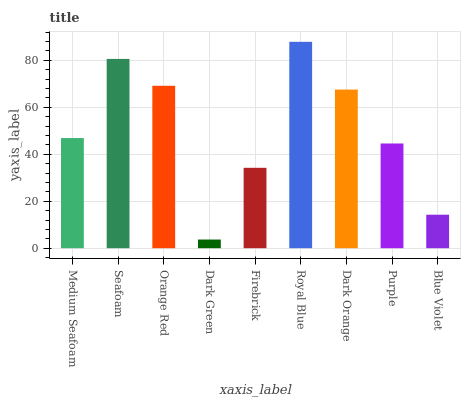Is Seafoam the minimum?
Answer yes or no. No. Is Seafoam the maximum?
Answer yes or no. No. Is Seafoam greater than Medium Seafoam?
Answer yes or no. Yes. Is Medium Seafoam less than Seafoam?
Answer yes or no. Yes. Is Medium Seafoam greater than Seafoam?
Answer yes or no. No. Is Seafoam less than Medium Seafoam?
Answer yes or no. No. Is Medium Seafoam the high median?
Answer yes or no. Yes. Is Medium Seafoam the low median?
Answer yes or no. Yes. Is Royal Blue the high median?
Answer yes or no. No. Is Royal Blue the low median?
Answer yes or no. No. 